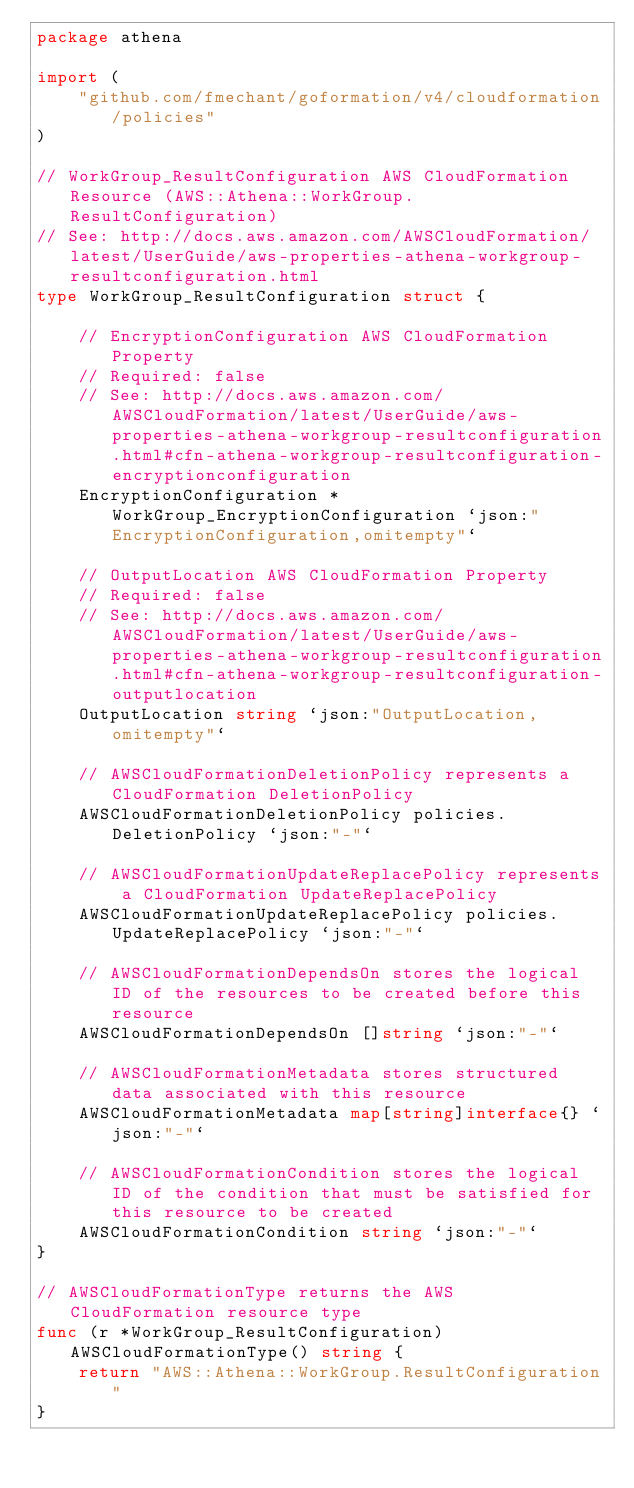<code> <loc_0><loc_0><loc_500><loc_500><_Go_>package athena

import (
	"github.com/fmechant/goformation/v4/cloudformation/policies"
)

// WorkGroup_ResultConfiguration AWS CloudFormation Resource (AWS::Athena::WorkGroup.ResultConfiguration)
// See: http://docs.aws.amazon.com/AWSCloudFormation/latest/UserGuide/aws-properties-athena-workgroup-resultconfiguration.html
type WorkGroup_ResultConfiguration struct {

	// EncryptionConfiguration AWS CloudFormation Property
	// Required: false
	// See: http://docs.aws.amazon.com/AWSCloudFormation/latest/UserGuide/aws-properties-athena-workgroup-resultconfiguration.html#cfn-athena-workgroup-resultconfiguration-encryptionconfiguration
	EncryptionConfiguration *WorkGroup_EncryptionConfiguration `json:"EncryptionConfiguration,omitempty"`

	// OutputLocation AWS CloudFormation Property
	// Required: false
	// See: http://docs.aws.amazon.com/AWSCloudFormation/latest/UserGuide/aws-properties-athena-workgroup-resultconfiguration.html#cfn-athena-workgroup-resultconfiguration-outputlocation
	OutputLocation string `json:"OutputLocation,omitempty"`

	// AWSCloudFormationDeletionPolicy represents a CloudFormation DeletionPolicy
	AWSCloudFormationDeletionPolicy policies.DeletionPolicy `json:"-"`

	// AWSCloudFormationUpdateReplacePolicy represents a CloudFormation UpdateReplacePolicy
	AWSCloudFormationUpdateReplacePolicy policies.UpdateReplacePolicy `json:"-"`

	// AWSCloudFormationDependsOn stores the logical ID of the resources to be created before this resource
	AWSCloudFormationDependsOn []string `json:"-"`

	// AWSCloudFormationMetadata stores structured data associated with this resource
	AWSCloudFormationMetadata map[string]interface{} `json:"-"`

	// AWSCloudFormationCondition stores the logical ID of the condition that must be satisfied for this resource to be created
	AWSCloudFormationCondition string `json:"-"`
}

// AWSCloudFormationType returns the AWS CloudFormation resource type
func (r *WorkGroup_ResultConfiguration) AWSCloudFormationType() string {
	return "AWS::Athena::WorkGroup.ResultConfiguration"
}
</code> 